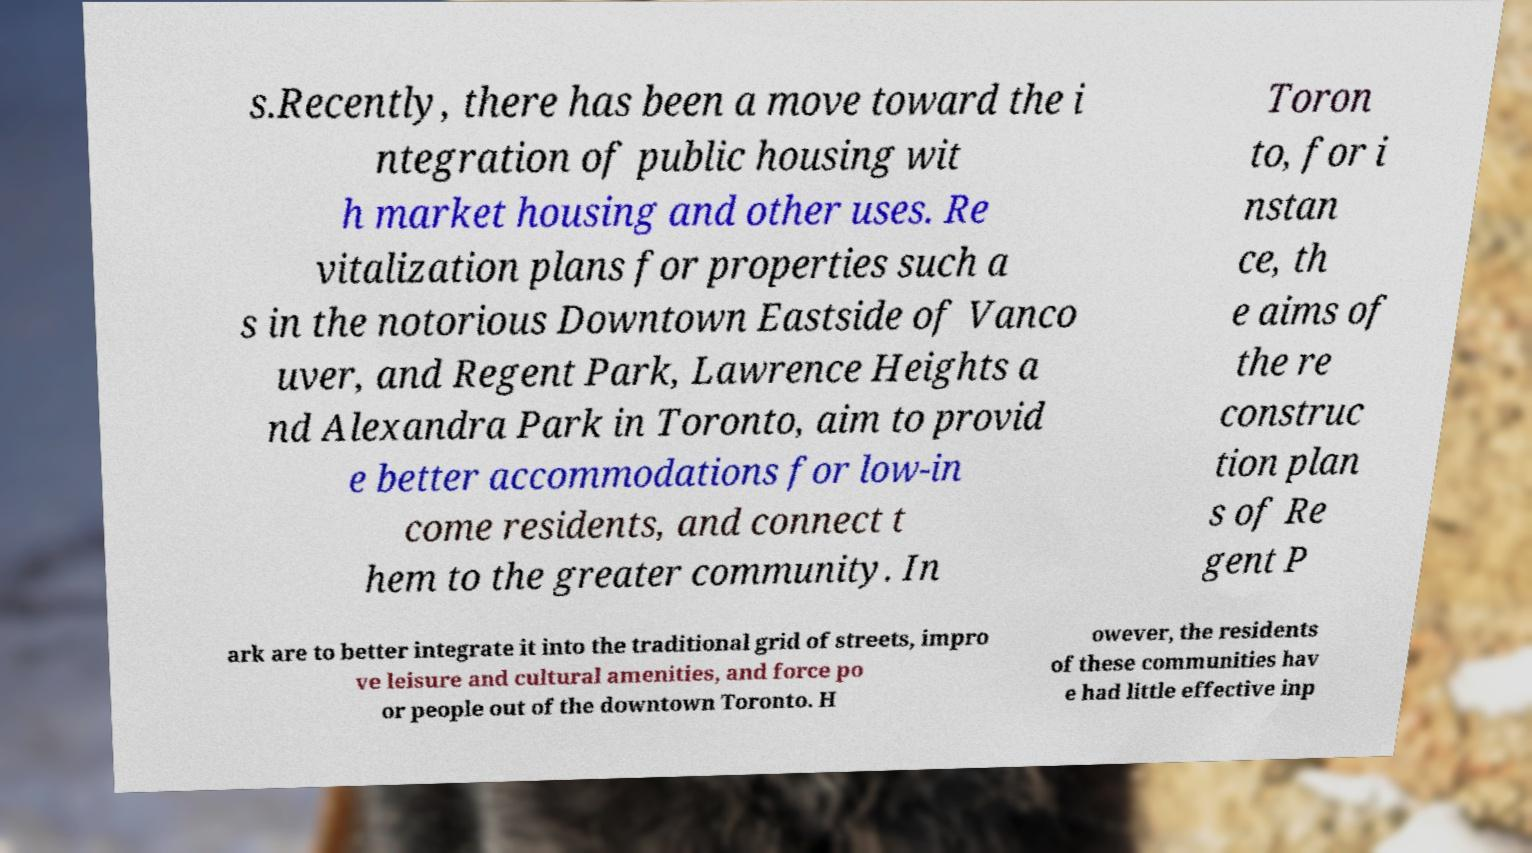Can you read and provide the text displayed in the image?This photo seems to have some interesting text. Can you extract and type it out for me? s.Recently, there has been a move toward the i ntegration of public housing wit h market housing and other uses. Re vitalization plans for properties such a s in the notorious Downtown Eastside of Vanco uver, and Regent Park, Lawrence Heights a nd Alexandra Park in Toronto, aim to provid e better accommodations for low-in come residents, and connect t hem to the greater community. In Toron to, for i nstan ce, th e aims of the re construc tion plan s of Re gent P ark are to better integrate it into the traditional grid of streets, impro ve leisure and cultural amenities, and force po or people out of the downtown Toronto. H owever, the residents of these communities hav e had little effective inp 